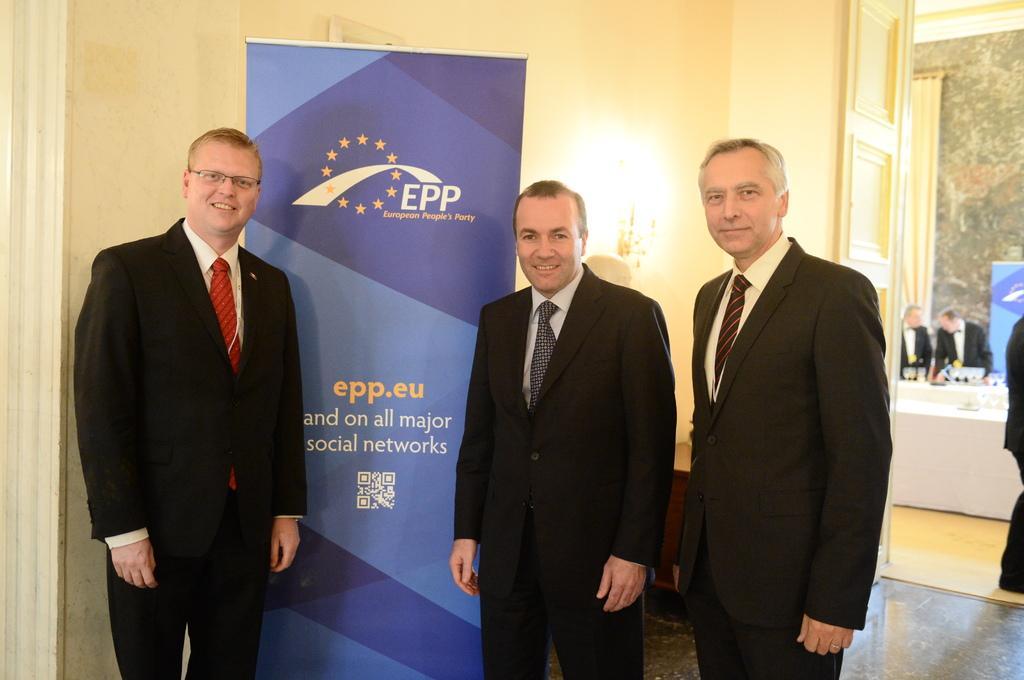Please provide a concise description of this image. In this image we can see a group of people standing on the floor. On the backside we can see a door, curtain, a lamp and a poster with some text on it. 